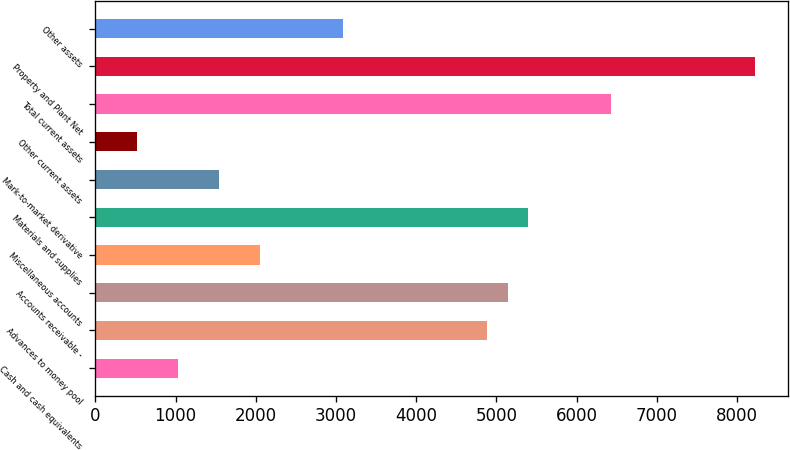Convert chart to OTSL. <chart><loc_0><loc_0><loc_500><loc_500><bar_chart><fcel>Cash and cash equivalents<fcel>Advances to money pool<fcel>Accounts receivable -<fcel>Miscellaneous accounts<fcel>Materials and supplies<fcel>Mark-to-market derivative<fcel>Other current assets<fcel>Total current assets<fcel>Property and Plant Net<fcel>Other assets<nl><fcel>1030<fcel>4885<fcel>5142<fcel>2058<fcel>5399<fcel>1544<fcel>516<fcel>6427<fcel>8226<fcel>3086<nl></chart> 